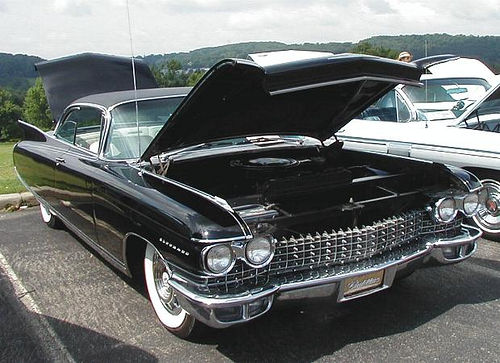What might be the purpose of the event where this photo was taken? Given the open hood and the general presentation of the car, the event is likely a classic car show or meet, where enthusiasts gather to display and admire vintage vehicles, share restoration tips, and celebrate automotive history. What would be a highlight feature of this car for enthusiasts? Enthusiasts would probably appreciate the car's distinctive tailfins, which are emblematic of the automotive design trends of the era. Additionally, the pristine condition of the car, with its shiny exterior and maintained chrome details, would make it a standout piece at the event. 